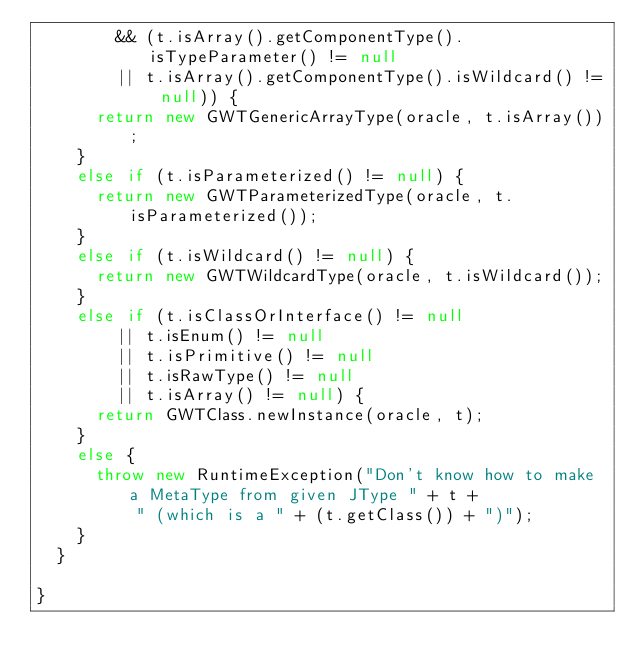Convert code to text. <code><loc_0><loc_0><loc_500><loc_500><_Java_>        && (t.isArray().getComponentType().isTypeParameter() != null
        || t.isArray().getComponentType().isWildcard() != null)) {
      return new GWTGenericArrayType(oracle, t.isArray());
    }
    else if (t.isParameterized() != null) {
      return new GWTParameterizedType(oracle, t.isParameterized());
    }
    else if (t.isWildcard() != null) {
      return new GWTWildcardType(oracle, t.isWildcard());
    }
    else if (t.isClassOrInterface() != null
        || t.isEnum() != null
        || t.isPrimitive() != null
        || t.isRawType() != null
        || t.isArray() != null) {
      return GWTClass.newInstance(oracle, t);
    }
    else {
      throw new RuntimeException("Don't know how to make a MetaType from given JType " + t +
          " (which is a " + (t.getClass()) + ")");
    }
  }

}
</code> 